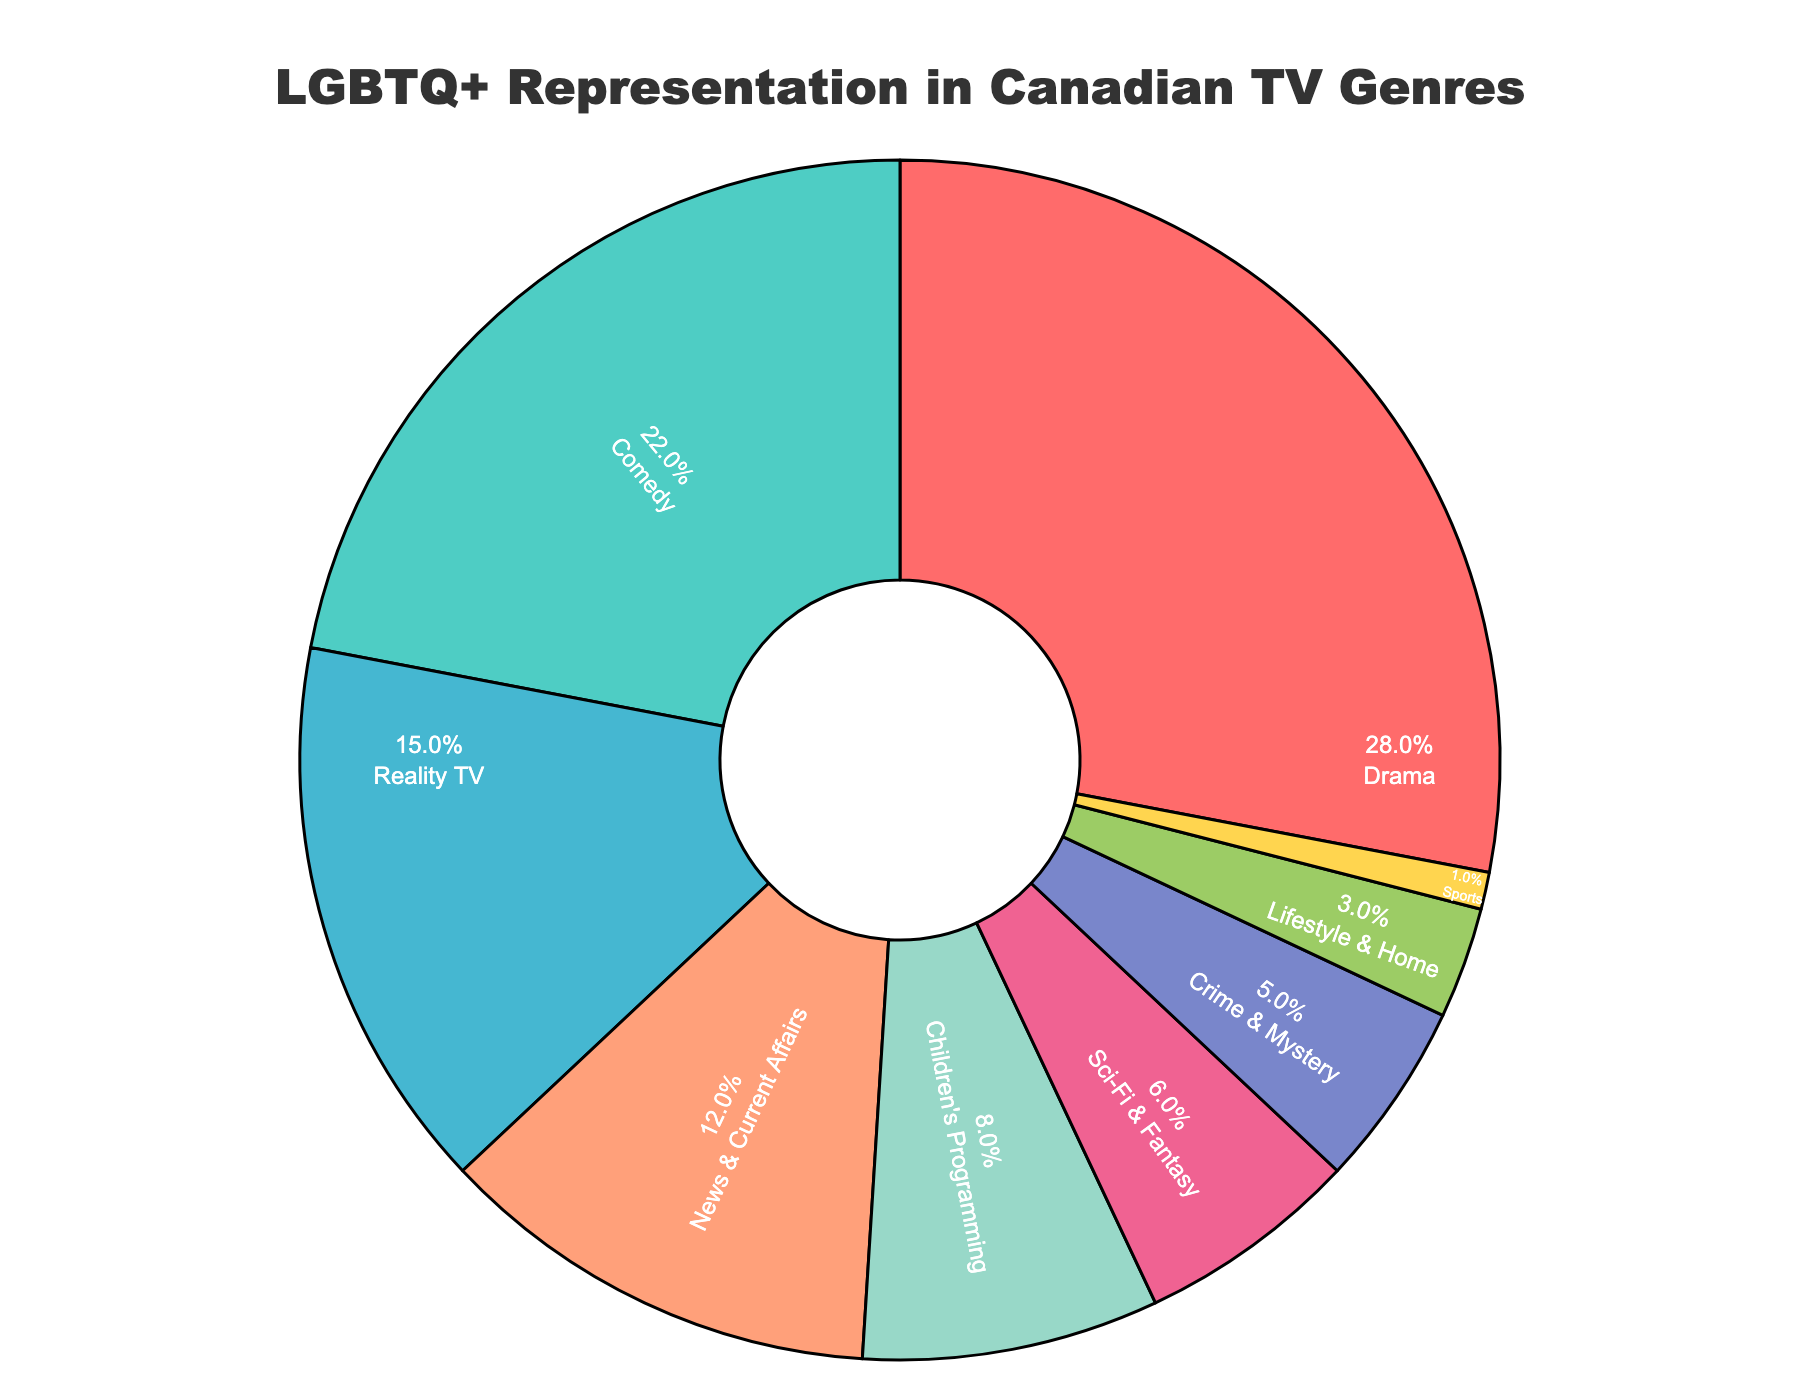Which genre has the highest percentage of LGBTQ+ representation in Canadian TV programming? Based on the figure, Drama has the largest section of the pie chart.
Answer: Drama Which two genres combined make up less than 10% of the total LGBTQ+ representation? Looking at the smallest sections of the pie chart, we see that Sports (1%) and Lifestyle & Home (3%) combined make up 4%, which is less than 10%.
Answer: Sports and Lifestyle & Home Is the LGBTQ+ representation in News & Current Affairs higher or lower than that in Reality TV? By observing the pie chart, News & Current Affairs is 12%, while Reality TV is 15%. Therefore, News & Current Affairs is lower.
Answer: Lower What percentage of LGBTQ+ representation is found in genres with less than 10% representation individually? Each genre with less than 10% are Sci-Fi & Fantasy (6%), Crime & Mystery (5%), Lifestyle & Home (3%), and Sports (1%). Summing these: 6% + 5% + 3% + 1% = 15%.
Answer: 15% Does Comedy have a higher or lower representation compared to significantly smaller categories like Crime & Mystery and Sci-Fi & Fantasy combined? Crime & Mystery and Sci-Fi & Fantasy together account for 5% + 6% = 11%. Comedy, on the other hand, is at 22%. Comedy has a higher representation.
Answer: Higher What is the total percentage of LGBTQ+ representation in the combination of Drama and Comedy? Sum the percentages of Drama (28%) and Comedy (22%): 28% + 22% = 50%.
Answer: 50% Which genre has a smaller representation: Children's Programming or Crime & Mystery? By comparing the two sections, Children's Programming has 8%, while Crime & Mystery has 5%. Hence, Crime & Mystery is smaller.
Answer: Crime & Mystery How many genres have at least 10% representation of LGBTQ+ characters? Genres with 10% or more representation are Drama (28%), Comedy (22%), Reality TV (15%), and News & Current Affairs (12%). Four genres meet this criterion.
Answer: Four genres Is the representation of LGBTQ+ characters in Children's Programming greater than that in Sci-Fi & Fantasy? Observing the pie chart, Children's Programming is at 8%, while Sci-Fi & Fantasy is at 6%. Therefore, Children's Programming has a higher representation.
Answer: Greater 